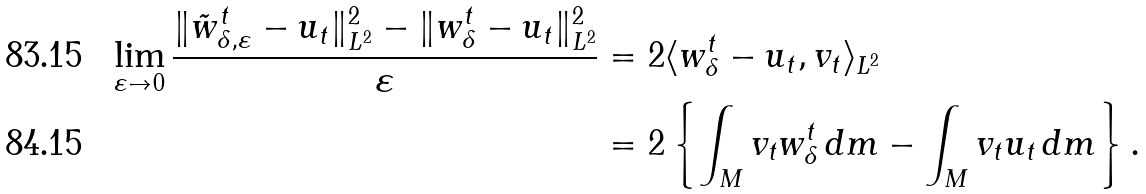Convert formula to latex. <formula><loc_0><loc_0><loc_500><loc_500>\lim _ { \varepsilon \to 0 } \frac { \| \tilde { w } ^ { t } _ { \delta , \varepsilon } - u _ { t } \| _ { L ^ { 2 } } ^ { 2 } - \| w ^ { t } _ { \delta } - u _ { t } \| _ { L ^ { 2 } } ^ { 2 } } { \varepsilon } & = 2 \langle w ^ { t } _ { \delta } - u _ { t } , v _ { t } \rangle _ { L ^ { 2 } } \\ & = 2 \left \{ \int _ { M } v _ { t } w ^ { t } _ { \delta } \, d m - \int _ { M } v _ { t } u _ { t } \, d m \right \} .</formula> 